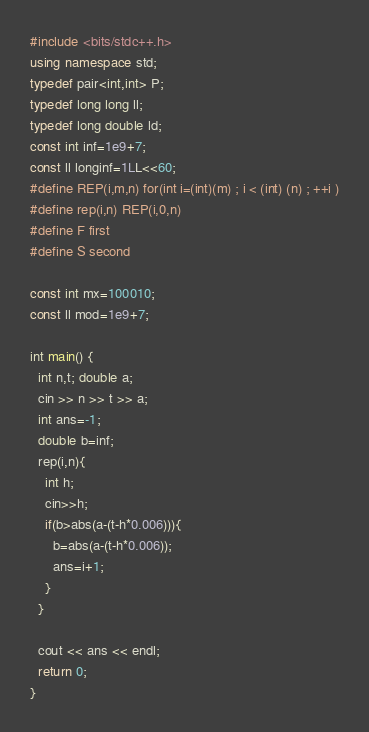Convert code to text. <code><loc_0><loc_0><loc_500><loc_500><_C++_>#include <bits/stdc++.h>
using namespace std;
typedef pair<int,int> P;
typedef long long ll;
typedef long double ld;
const int inf=1e9+7;
const ll longinf=1LL<<60;
#define REP(i,m,n) for(int i=(int)(m) ; i < (int) (n) ; ++i )
#define rep(i,n) REP(i,0,n)
#define F first
#define S second

const int mx=100010;
const ll mod=1e9+7;

int main() {
  int n,t; double a;
  cin >> n >> t >> a;
  int ans=-1;
  double b=inf;
  rep(i,n){
    int h;
    cin>>h;
    if(b>abs(a-(t-h*0.006))){
      b=abs(a-(t-h*0.006));
      ans=i+1;
    }
  }

  cout << ans << endl;
  return 0;
}
</code> 